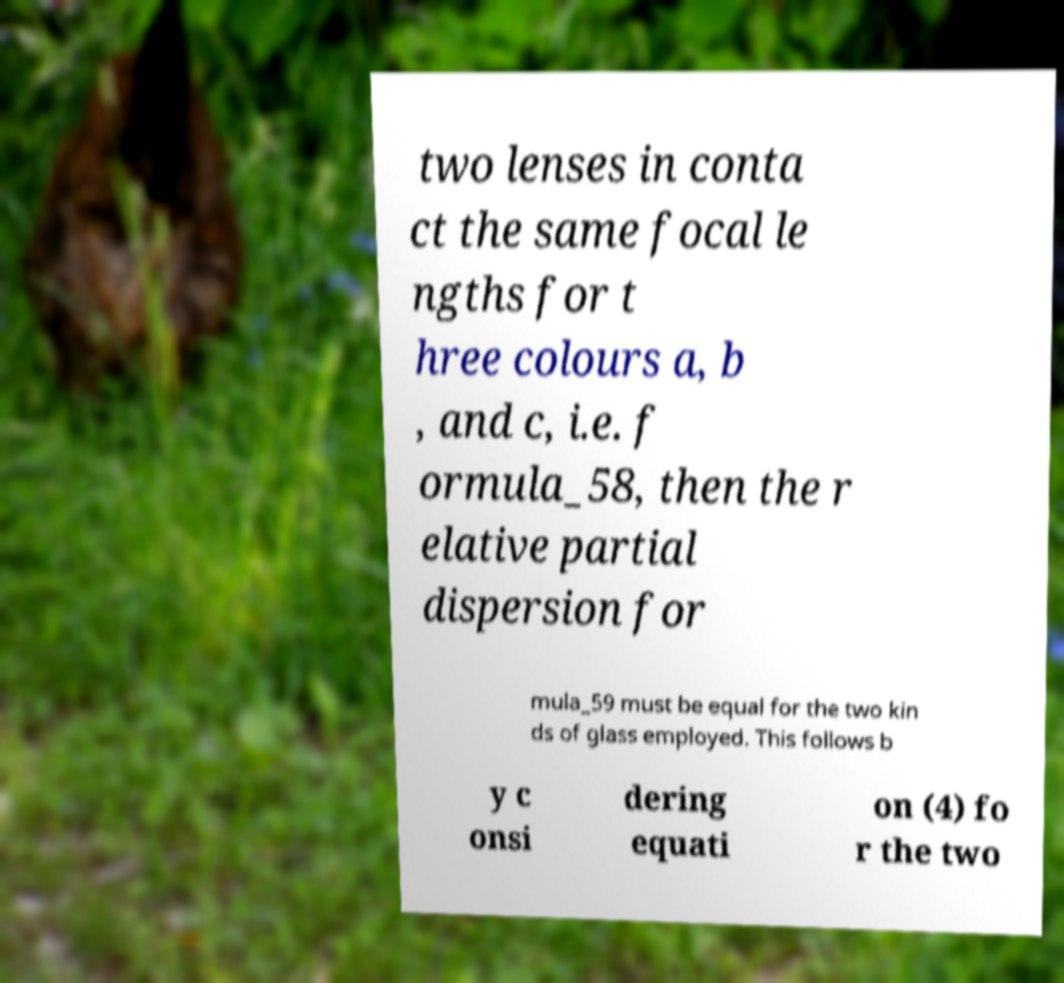For documentation purposes, I need the text within this image transcribed. Could you provide that? two lenses in conta ct the same focal le ngths for t hree colours a, b , and c, i.e. f ormula_58, then the r elative partial dispersion for mula_59 must be equal for the two kin ds of glass employed. This follows b y c onsi dering equati on (4) fo r the two 